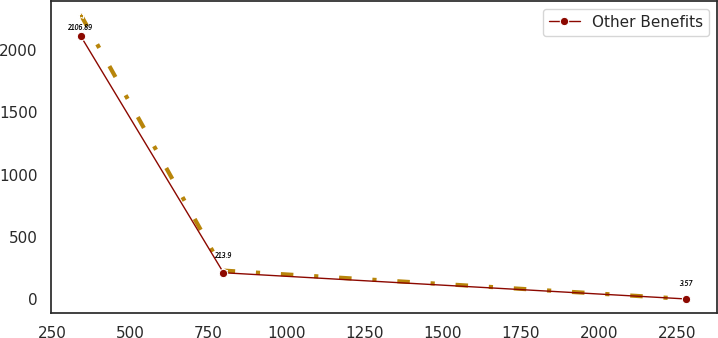Convert chart to OTSL. <chart><loc_0><loc_0><loc_500><loc_500><line_chart><ecel><fcel>Unnamed: 1<fcel>Other Benefits<nl><fcel>341.85<fcel>2277.55<fcel>2106.89<nl><fcel>797.99<fcel>231.01<fcel>213.9<nl><fcel>2279.52<fcel>3.62<fcel>3.57<nl></chart> 